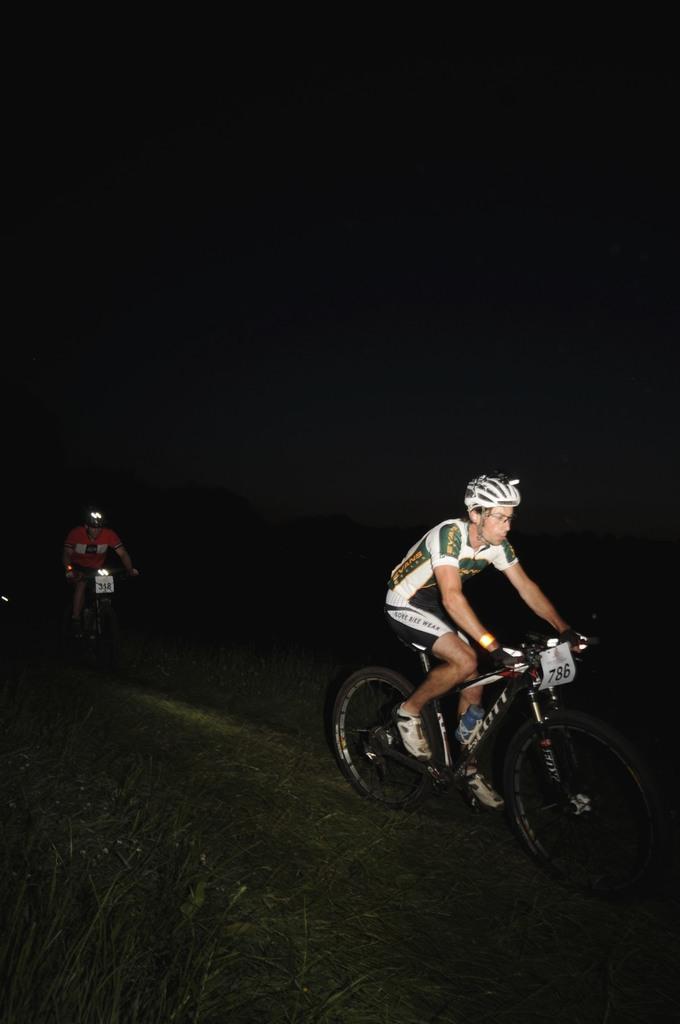Could you give a brief overview of what you see in this image? In this picture couple of men riding bicycles and they are wearing helmets on their heads and I can see dark background. 